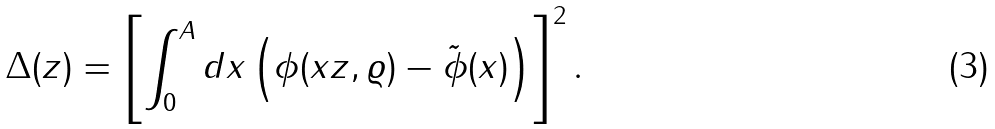<formula> <loc_0><loc_0><loc_500><loc_500>\Delta ( z ) = \left [ \int _ { 0 } ^ { A } d x \left ( \phi ( x z , \varrho ) - \tilde { \phi } ( x ) \right ) \right ] ^ { 2 } .</formula> 